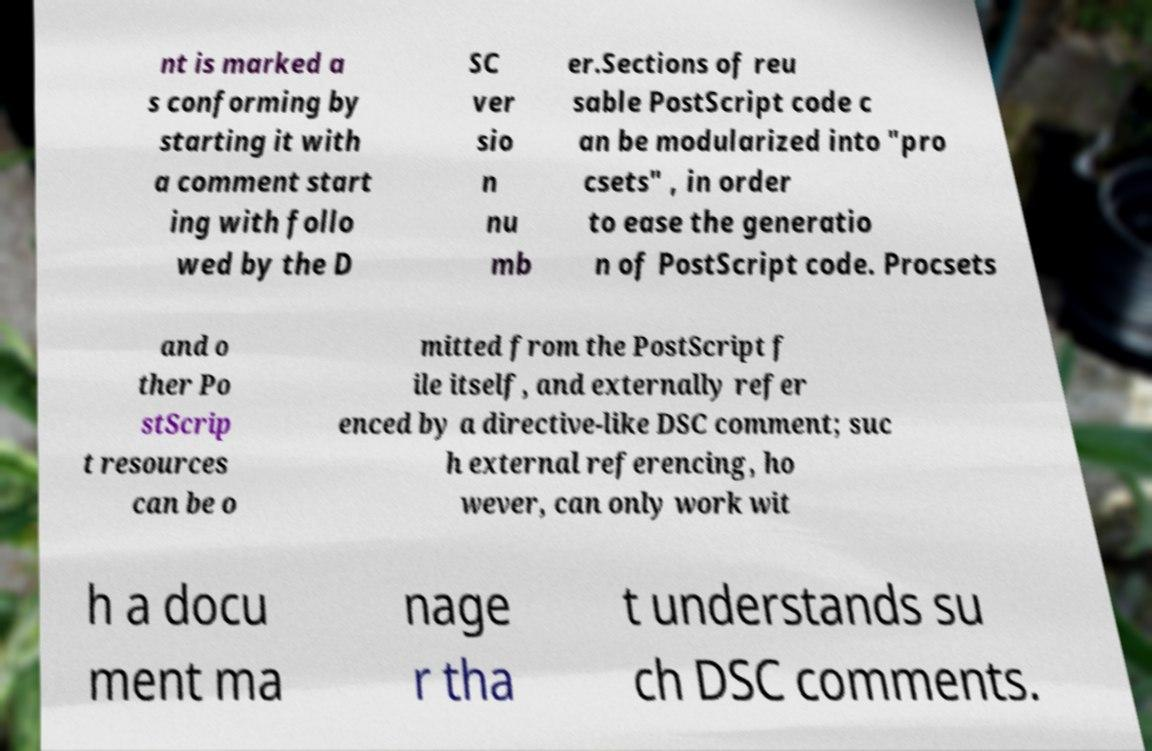Can you read and provide the text displayed in the image?This photo seems to have some interesting text. Can you extract and type it out for me? nt is marked a s conforming by starting it with a comment start ing with follo wed by the D SC ver sio n nu mb er.Sections of reu sable PostScript code c an be modularized into "pro csets" , in order to ease the generatio n of PostScript code. Procsets and o ther Po stScrip t resources can be o mitted from the PostScript f ile itself, and externally refer enced by a directive-like DSC comment; suc h external referencing, ho wever, can only work wit h a docu ment ma nage r tha t understands su ch DSC comments. 